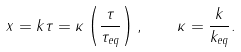Convert formula to latex. <formula><loc_0><loc_0><loc_500><loc_500>x = k \tau = \kappa \left ( \frac { \tau } { \tau _ { e q } } \right ) , \quad \kappa = \frac { k } { k _ { e q } } .</formula> 